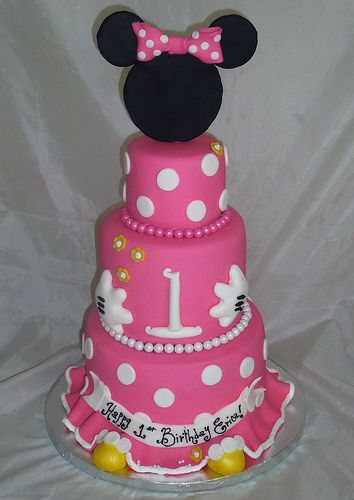<image>
Is there a mouse behind the cake? No. The mouse is not behind the cake. From this viewpoint, the mouse appears to be positioned elsewhere in the scene. 